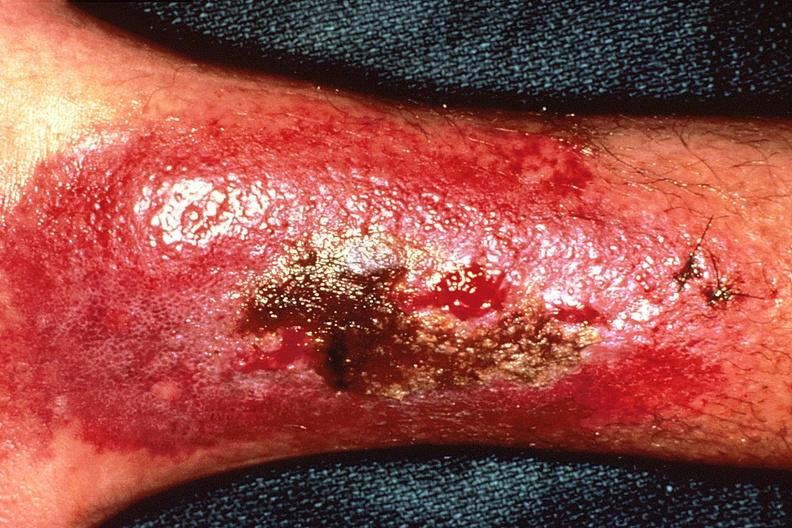does this image show bacterial dematitis at site of skin biopsy?
Answer the question using a single word or phrase. Yes 